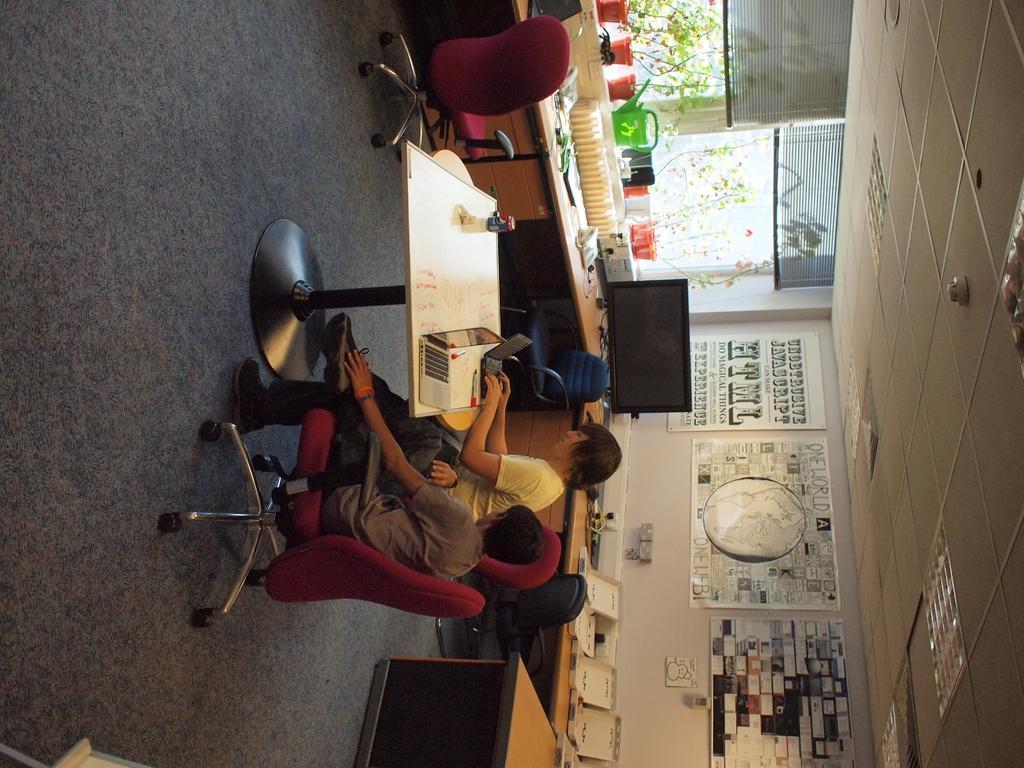Can you describe this image briefly? This picture is an inside view of a room. In the center of the image there is a table. On the table we can see laptops, pen, bottle. Beside the table two persons are sitting on a chair. In this picture we can see chairs, pots, plants, curtains, boards, wall and some objects, tables. On the left side of the image we can see the floor. On the right side of the image we can see the roof and lights. 